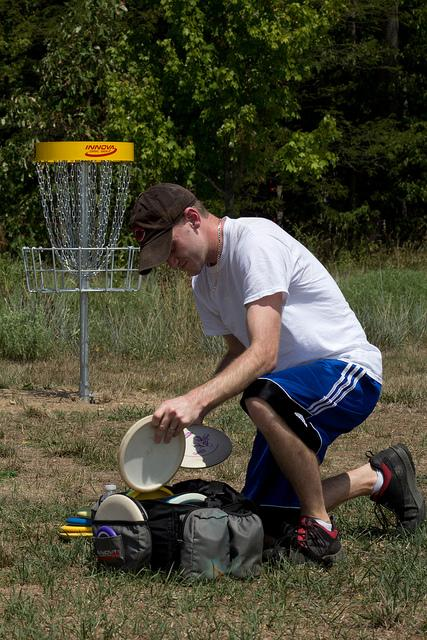The man has what on his head? hat 